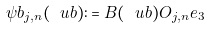Convert formula to latex. <formula><loc_0><loc_0><loc_500><loc_500>\psi b _ { j , n } ( \ u b ) \colon = B ( \ u b ) O _ { j , n } e _ { 3 }</formula> 